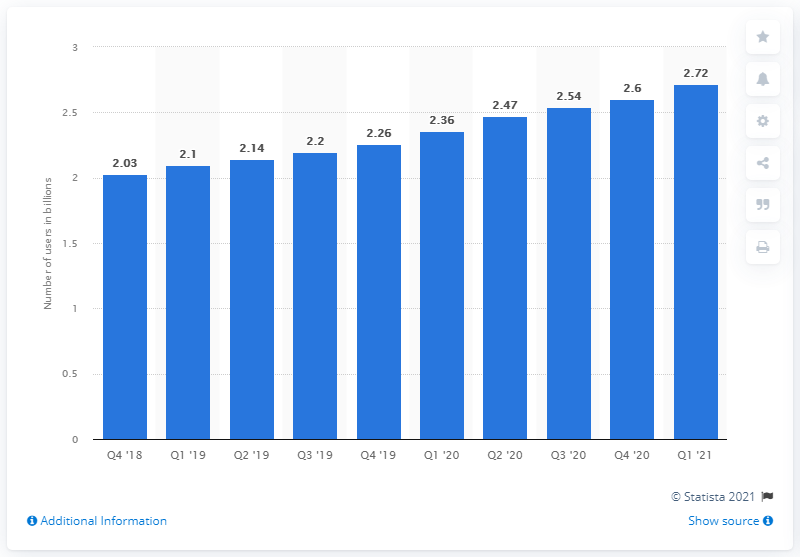Mention a couple of crucial points in this snapshot. Out of all individuals who utilized at least one of the company's primary offerings on a daily basis, 2.72 were identified. 